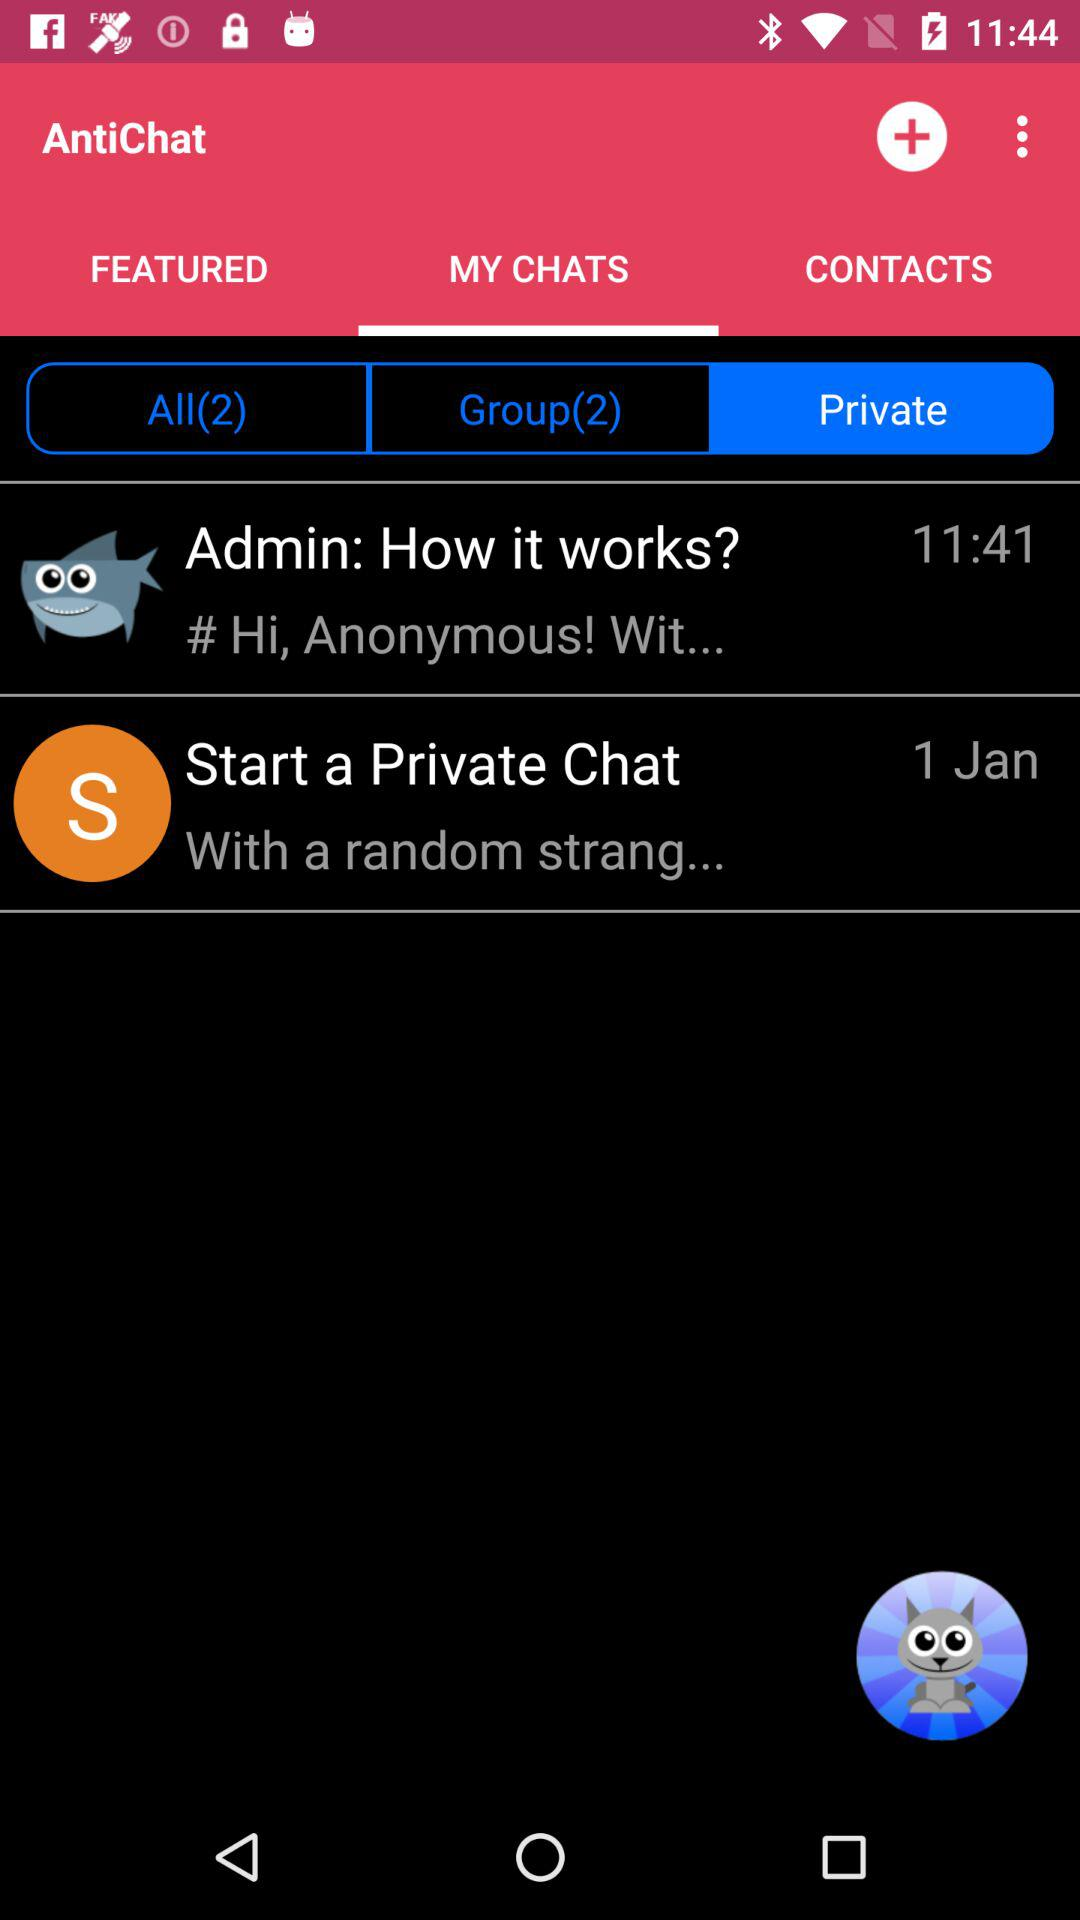Which option is selected in "MY CHATS"? The selected option in "MY CHATS" is "Private". 